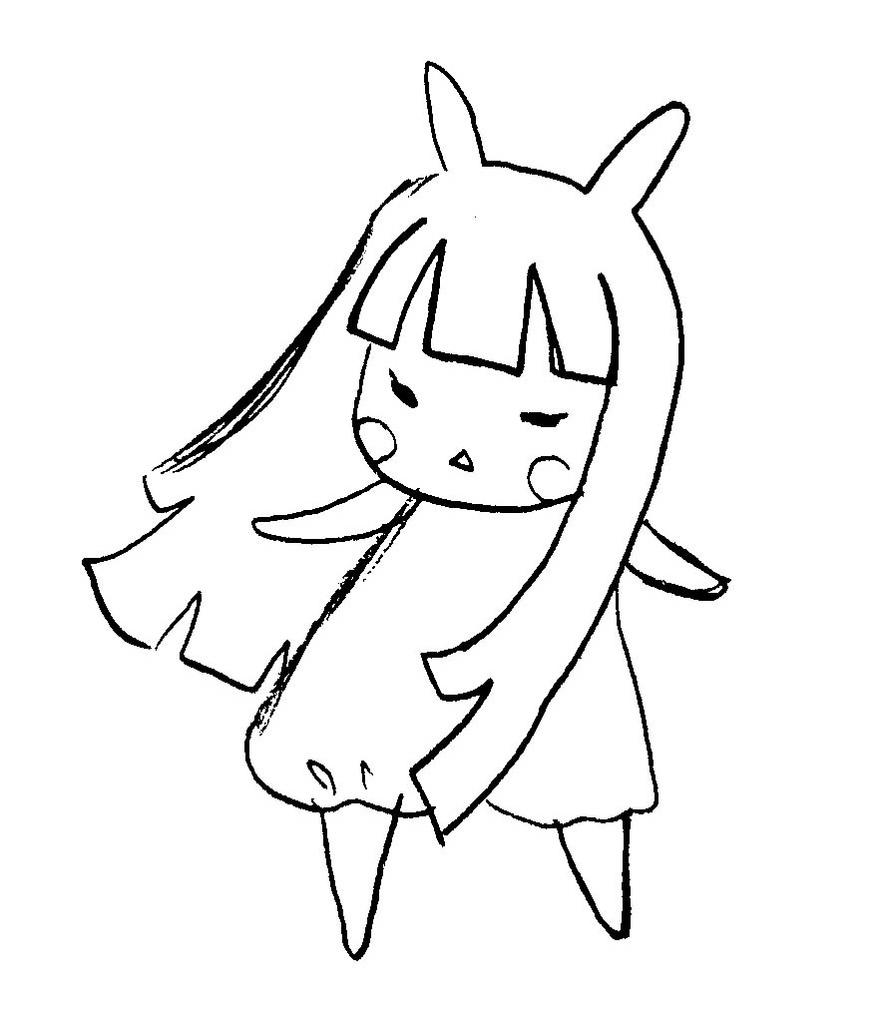What is the main subject of the image? The image contains line art of a girl or a doll. What color is the background of the image? The background of the image is white in color. What flavor of tea is being prepared in the kettle in the image? There is no kettle present in the image, so it is not possible to determine the flavor of tea being prepared. 